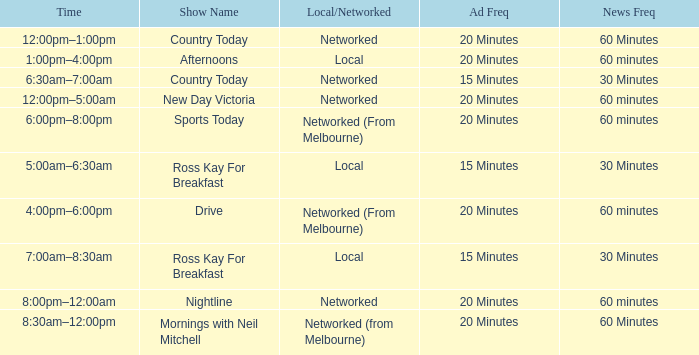What Time has a Show Name of mornings with neil mitchell? 8:30am–12:00pm. 